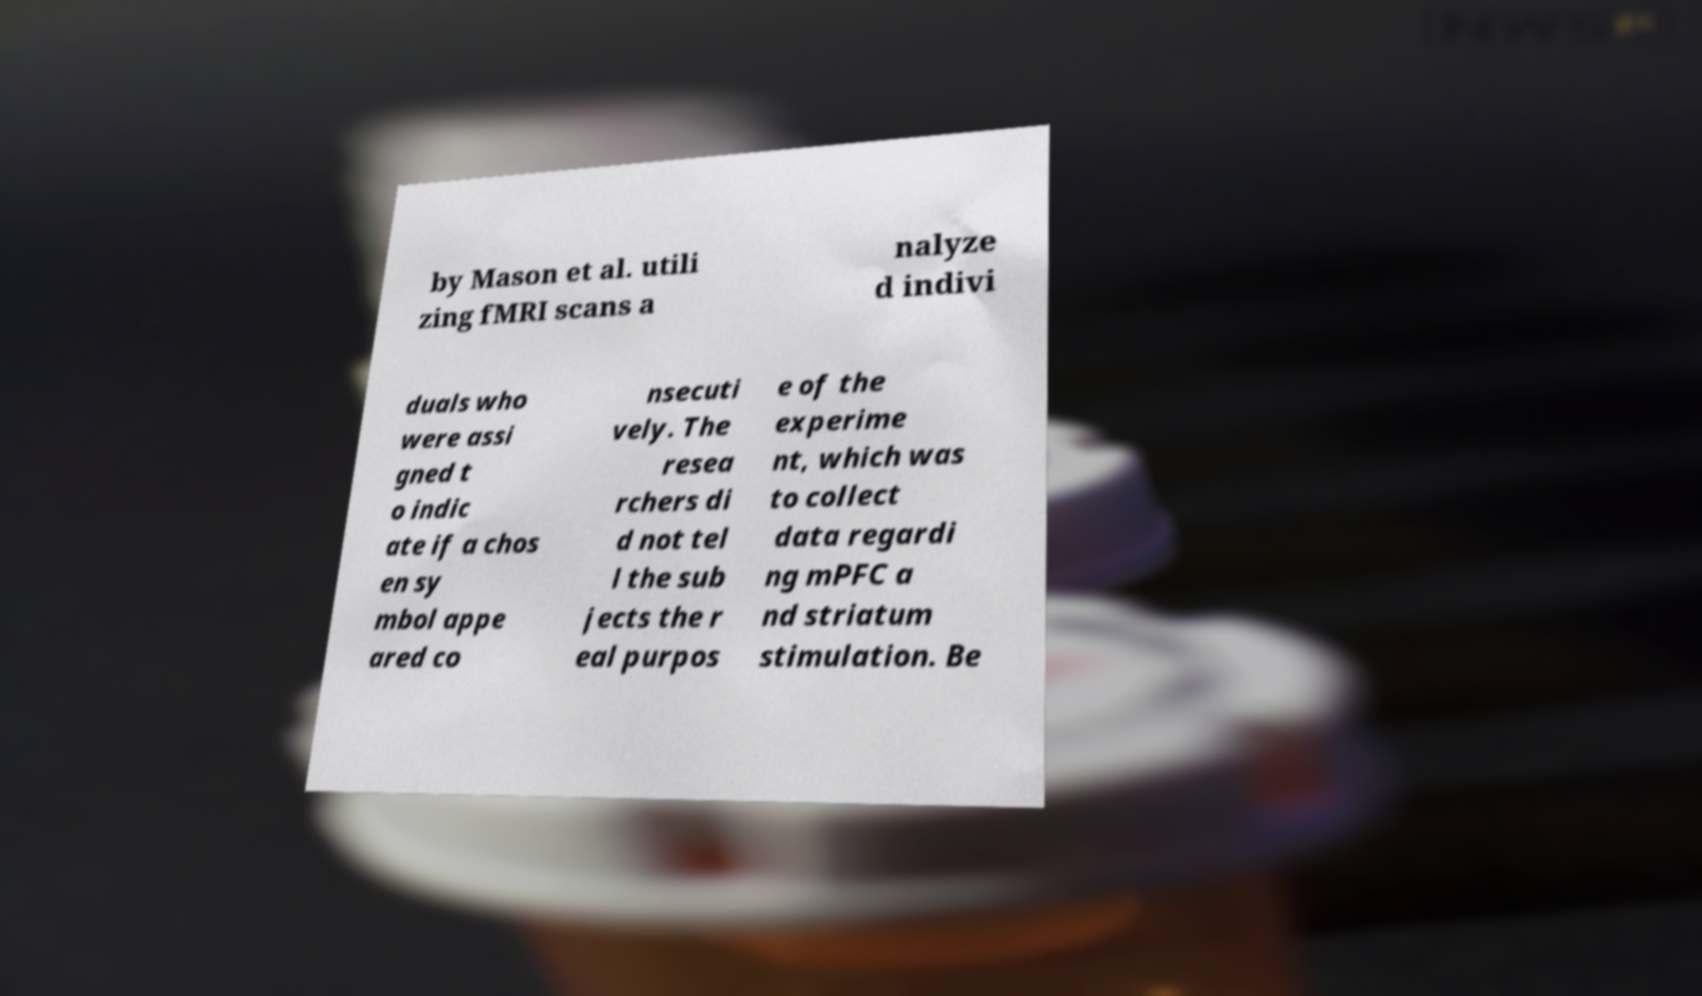What messages or text are displayed in this image? I need them in a readable, typed format. by Mason et al. utili zing fMRI scans a nalyze d indivi duals who were assi gned t o indic ate if a chos en sy mbol appe ared co nsecuti vely. The resea rchers di d not tel l the sub jects the r eal purpos e of the experime nt, which was to collect data regardi ng mPFC a nd striatum stimulation. Be 